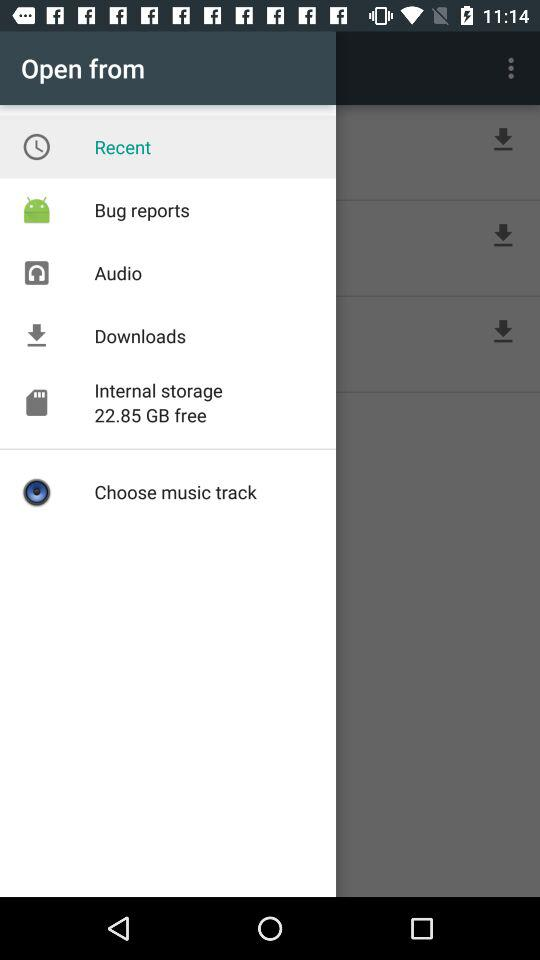Which option is selected? The selected option is "Recent". 